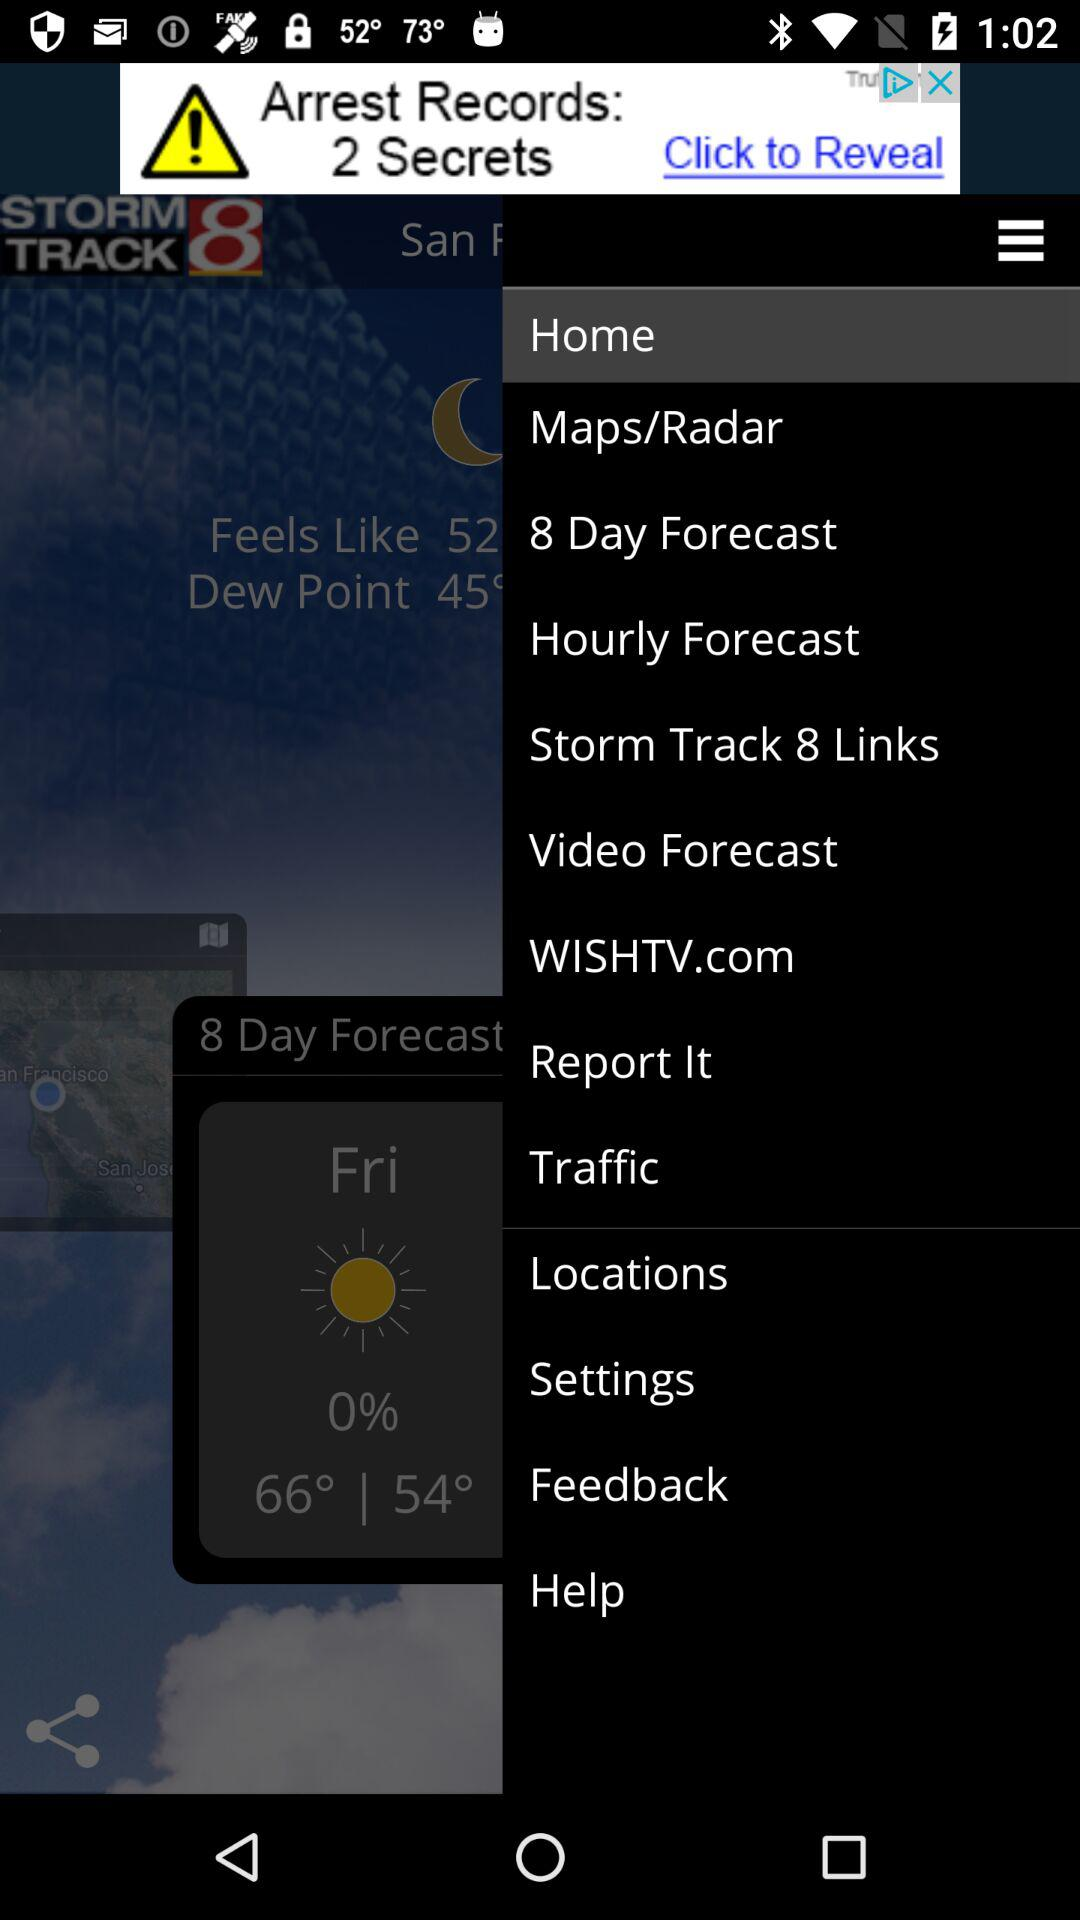How many degrees Fahrenheit is the difference between the high and low temperatures?
Answer the question using a single word or phrase. 12 